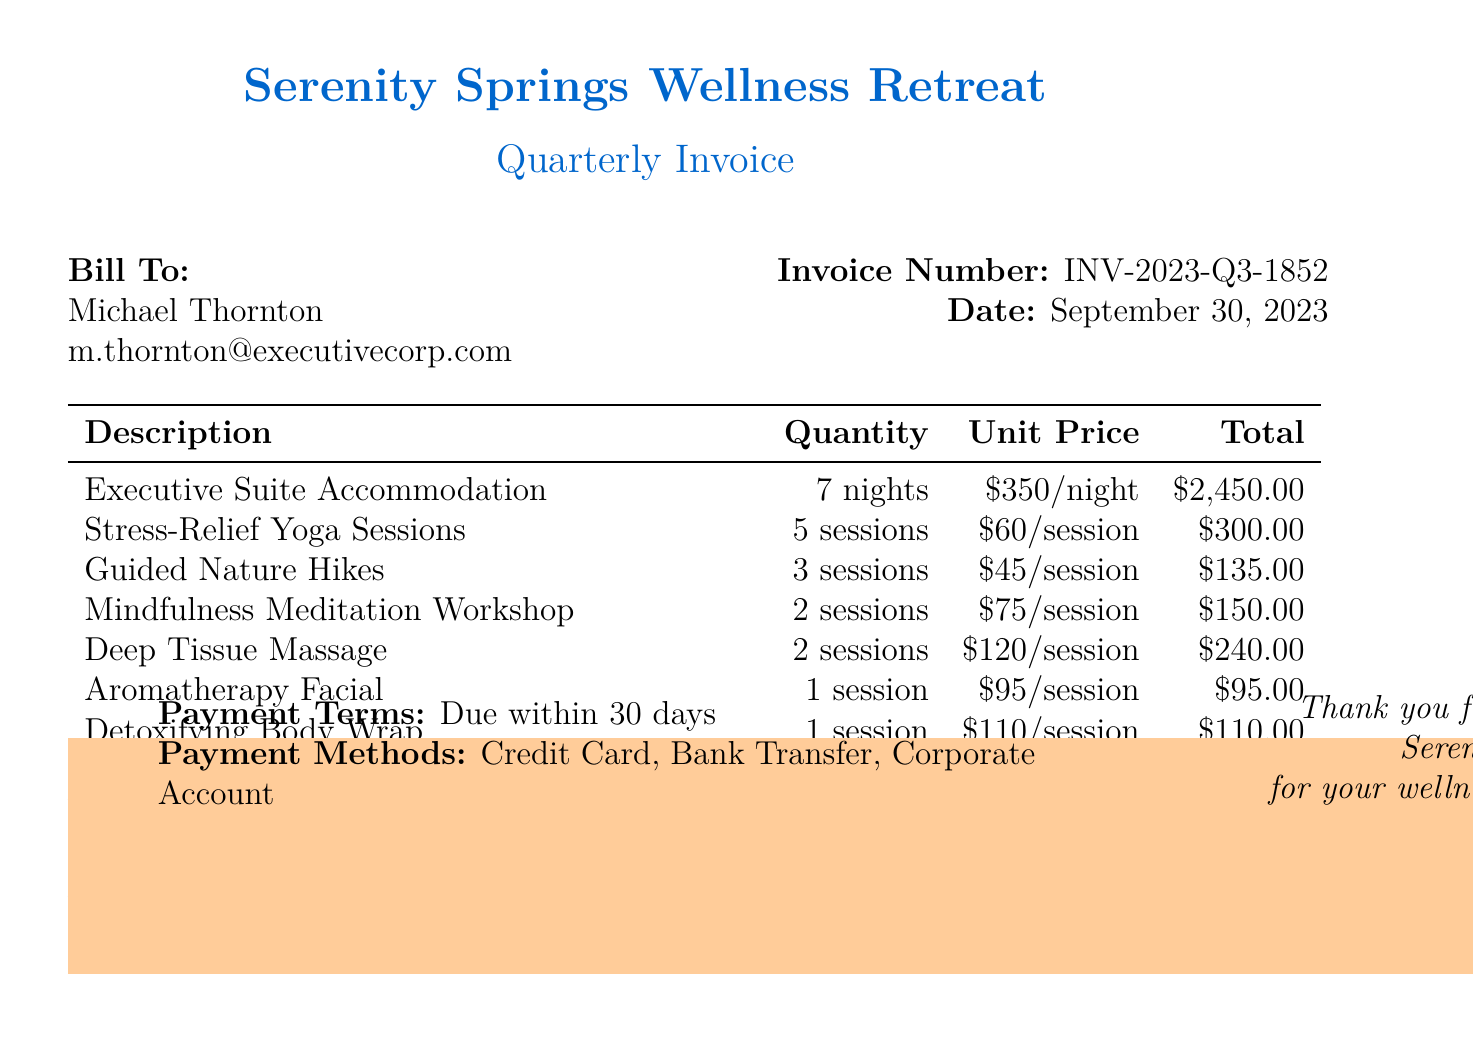What is the invoice number? The invoice number is clearly listed under the invoice details.
Answer: INV-2023-Q3-1852 What is the date of the invoice? The date is specified at the top right section of the bill.
Answer: September 30, 2023 How many nights is the accommodation for? The quantity of nights for the accommodation is specified in the description.
Answer: 7 nights What is the total for the Stress-Relief Yoga Sessions? The total is calculated based on the quantity and unit price for that service.
Answer: $300.00 What is the subtotal amount? The subtotal is shown before the tax calculation, summarizing all services.
Answer: $4,075.00 What percentage is the tax applied? The tax is clearly mentioned along with the rate in the document.
Answer: 8% What is the total amount due? The total due is the final amount listed at the bottom after tax.
Answer: $4,401.00 What methods of payment are accepted? The document specifies payment methods in the payment terms section.
Answer: Credit Card, Bank Transfer, Corporate Account How many sessions of Guided Nature Hikes are included? The quantity of sessions is provided in the description of the activities.
Answer: 3 sessions 